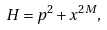<formula> <loc_0><loc_0><loc_500><loc_500>H = p ^ { 2 } + x ^ { 2 M } ,</formula> 